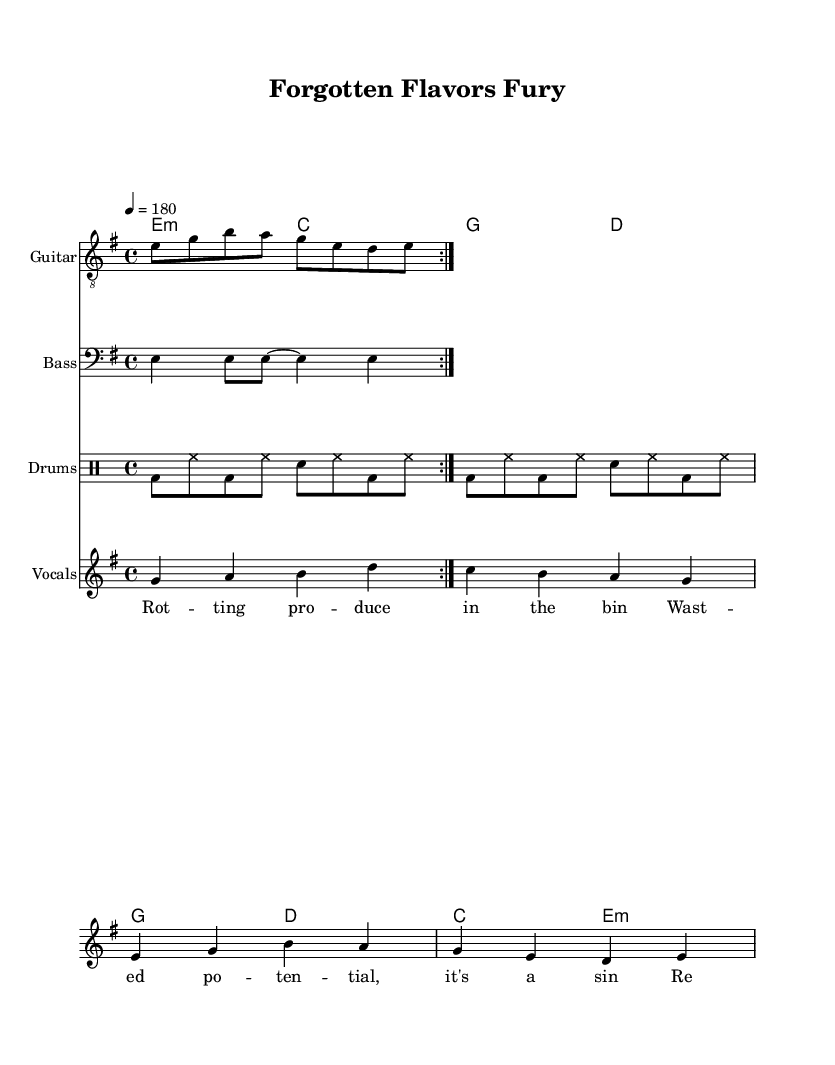What is the key signature of this music? The key signature indicates the piece is in E minor, which has one sharp (F#).
Answer: E minor What is the time signature of the music? The time signature, shown at the beginning of the score, is 4/4, indicating four beats per measure.
Answer: 4/4 What is the tempo marking for this piece? The tempo marking specifies a speed of 180 beats per minute, shown with the tempo indication "4 = 180".
Answer: 180 How many measures are in the verse section? By counting the measures in the 'vocals' staff, there are four measures in the verse section before it transitions to the chorus.
Answer: 4 What is the phrase that captures the energy of the chorus? The chorus consists of a repeated call to action, which is "Reclaim the waste, ignite the taste." This reflects the punk spirit of urgency and defiance.
Answer: Reclaim the waste, ignite the taste What instruments are used in this punk piece? The score includes parts for guitar, bass, drums, and vocals, showcasing a typical punk band lineup.
Answer: Guitar, Bass, Drums, Vocals What message does the music advocate for? The lyrics emphasize reclaiming forgotten ingredients and raising awareness about food waste, presenting a passionate call to action through the punk genre.
Answer: Reclaiming food waste 